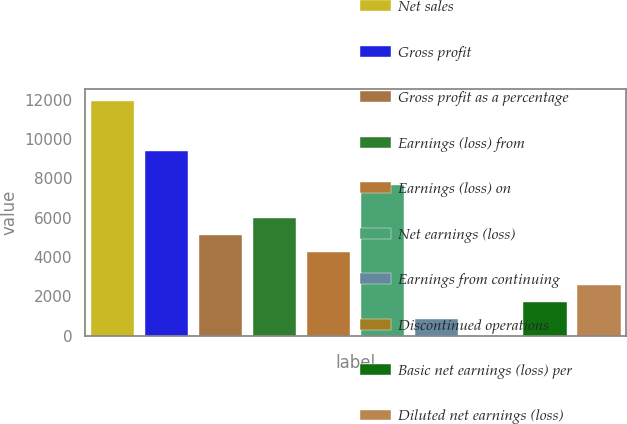Convert chart to OTSL. <chart><loc_0><loc_0><loc_500><loc_500><bar_chart><fcel>Net sales<fcel>Gross profit<fcel>Gross profit as a percentage<fcel>Earnings (loss) from<fcel>Earnings (loss) on<fcel>Net earnings (loss)<fcel>Earnings from continuing<fcel>Discontinued operations<fcel>Basic net earnings (loss) per<fcel>Diluted net earnings (loss)<nl><fcel>11937<fcel>9379.13<fcel>5115.93<fcel>5968.57<fcel>4263.29<fcel>7673.85<fcel>852.73<fcel>0.09<fcel>1705.37<fcel>2558.01<nl></chart> 